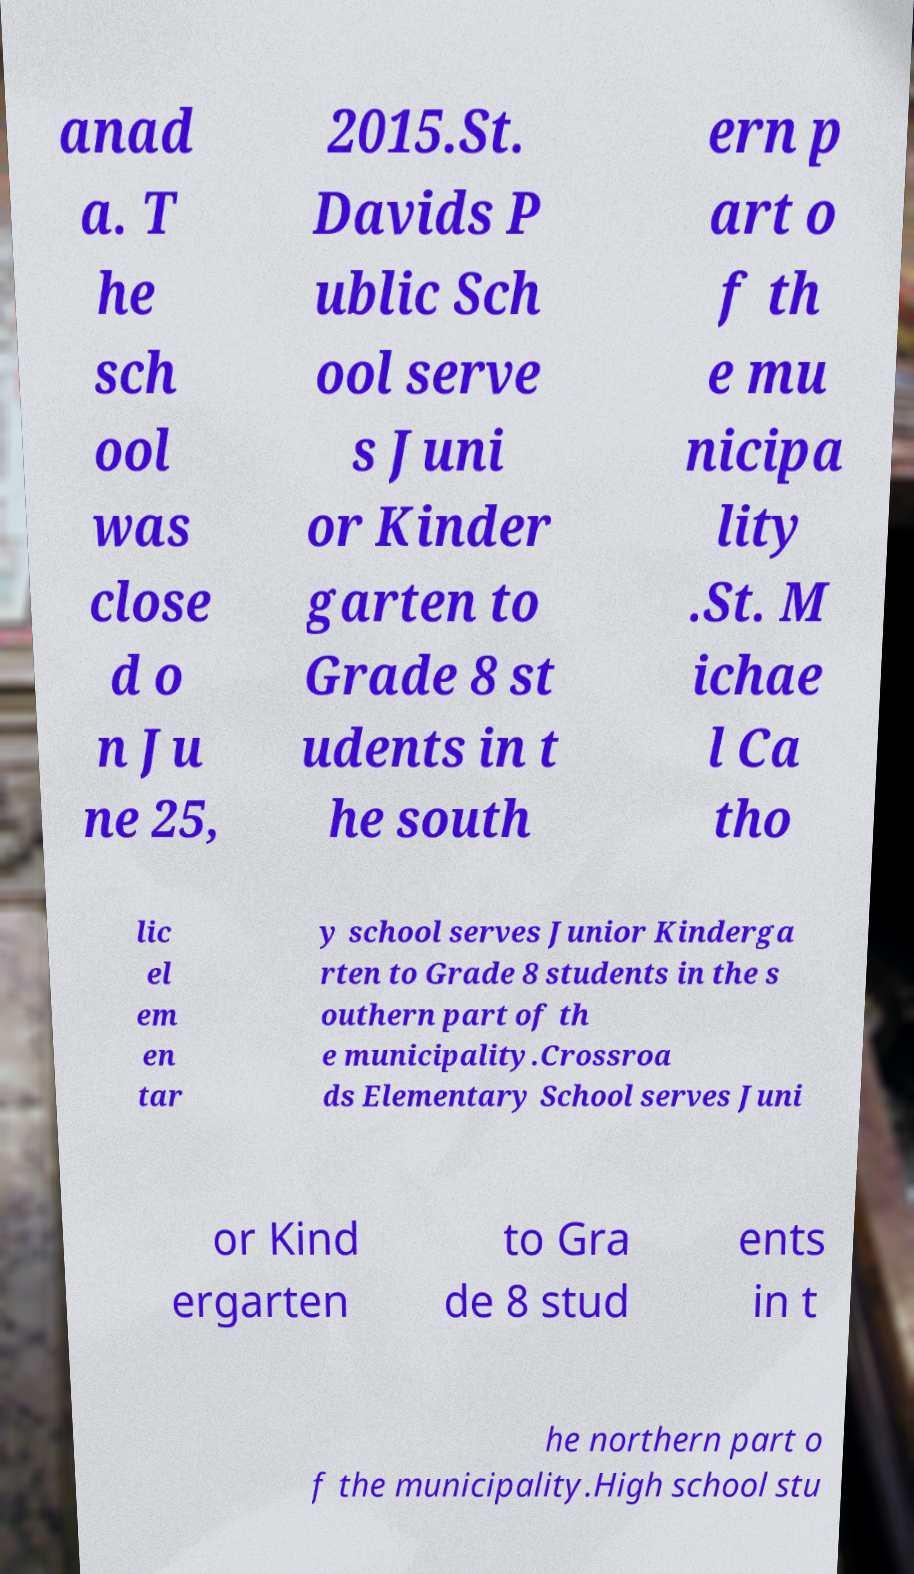I need the written content from this picture converted into text. Can you do that? anad a. T he sch ool was close d o n Ju ne 25, 2015.St. Davids P ublic Sch ool serve s Juni or Kinder garten to Grade 8 st udents in t he south ern p art o f th e mu nicipa lity .St. M ichae l Ca tho lic el em en tar y school serves Junior Kinderga rten to Grade 8 students in the s outhern part of th e municipality.Crossroa ds Elementary School serves Juni or Kind ergarten to Gra de 8 stud ents in t he northern part o f the municipality.High school stu 